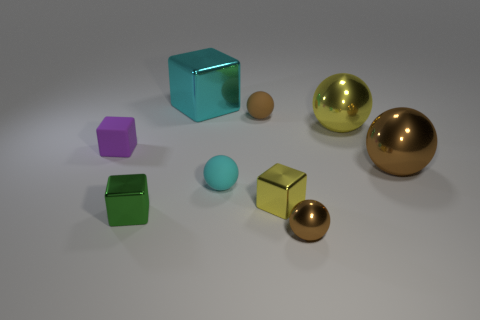How many brown spheres must be subtracted to get 1 brown spheres? 2 Subtract 1 balls. How many balls are left? 4 Subtract all purple cylinders. How many brown balls are left? 3 Subtract all cyan spheres. How many spheres are left? 4 Subtract all yellow shiny spheres. How many spheres are left? 4 Subtract all yellow balls. Subtract all cyan cubes. How many balls are left? 4 Subtract all cubes. How many objects are left? 5 Subtract all small red metallic cylinders. Subtract all small matte cubes. How many objects are left? 8 Add 4 tiny cyan matte balls. How many tiny cyan matte balls are left? 5 Add 1 small brown metallic things. How many small brown metallic things exist? 2 